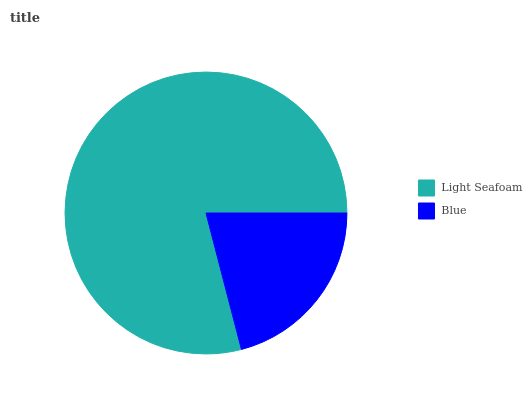Is Blue the minimum?
Answer yes or no. Yes. Is Light Seafoam the maximum?
Answer yes or no. Yes. Is Blue the maximum?
Answer yes or no. No. Is Light Seafoam greater than Blue?
Answer yes or no. Yes. Is Blue less than Light Seafoam?
Answer yes or no. Yes. Is Blue greater than Light Seafoam?
Answer yes or no. No. Is Light Seafoam less than Blue?
Answer yes or no. No. Is Light Seafoam the high median?
Answer yes or no. Yes. Is Blue the low median?
Answer yes or no. Yes. Is Blue the high median?
Answer yes or no. No. Is Light Seafoam the low median?
Answer yes or no. No. 